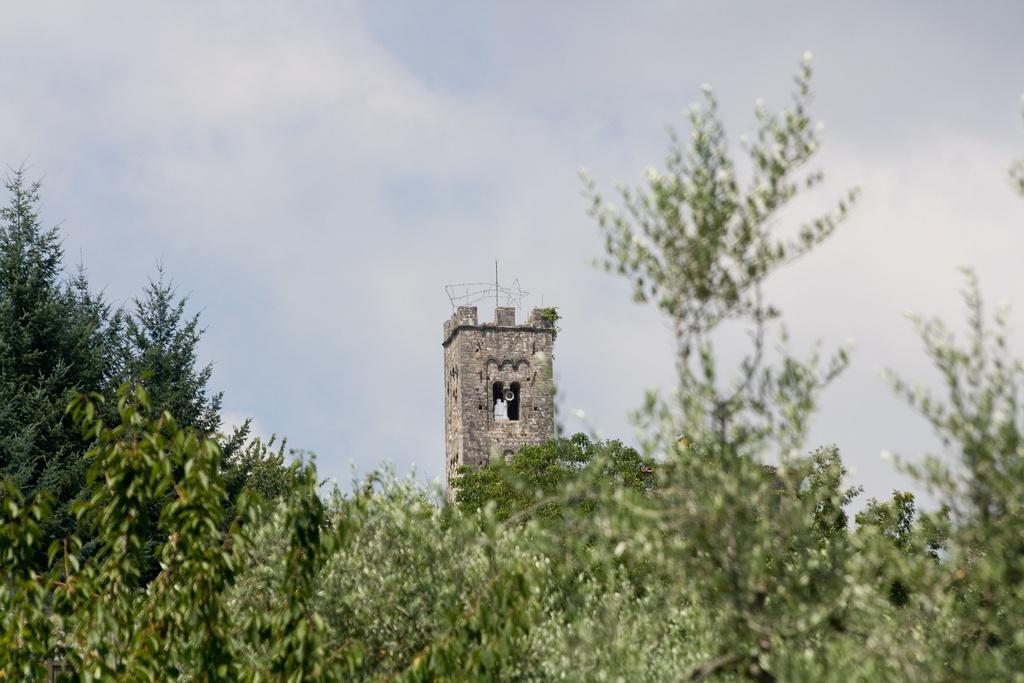Can you describe this image briefly? In the picture I can see trees and a building tower. In the background I can see the sky. 